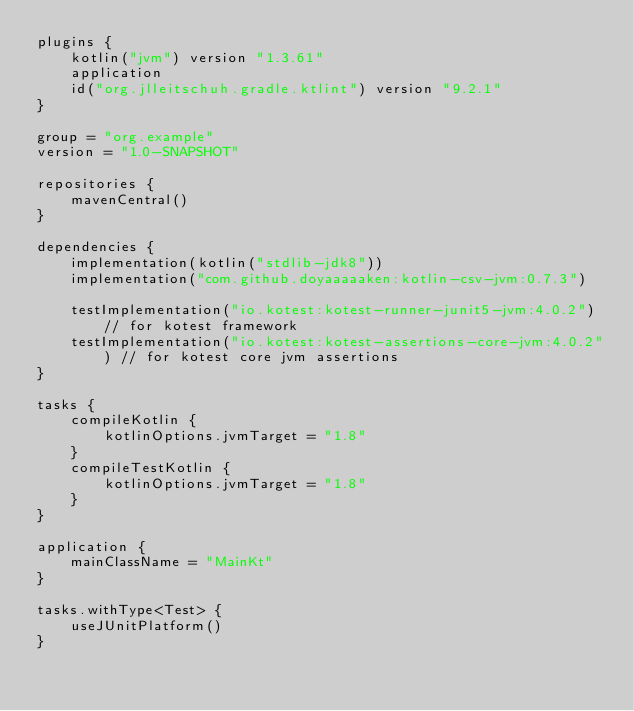Convert code to text. <code><loc_0><loc_0><loc_500><loc_500><_Kotlin_>plugins {
    kotlin("jvm") version "1.3.61"
    application
    id("org.jlleitschuh.gradle.ktlint") version "9.2.1"
}

group = "org.example"
version = "1.0-SNAPSHOT"

repositories {
    mavenCentral()
}

dependencies {
    implementation(kotlin("stdlib-jdk8"))
    implementation("com.github.doyaaaaaken:kotlin-csv-jvm:0.7.3")

    testImplementation("io.kotest:kotest-runner-junit5-jvm:4.0.2") // for kotest framework
    testImplementation("io.kotest:kotest-assertions-core-jvm:4.0.2") // for kotest core jvm assertions
}

tasks {
    compileKotlin {
        kotlinOptions.jvmTarget = "1.8"
    }
    compileTestKotlin {
        kotlinOptions.jvmTarget = "1.8"
    }
}

application {
    mainClassName = "MainKt"
}

tasks.withType<Test> {
    useJUnitPlatform()
}</code> 